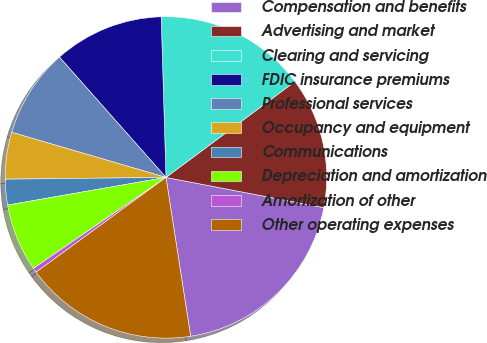<chart> <loc_0><loc_0><loc_500><loc_500><pie_chart><fcel>Compensation and benefits<fcel>Advertising and market<fcel>Clearing and servicing<fcel>FDIC insurance premiums<fcel>Professional services<fcel>Occupancy and equipment<fcel>Communications<fcel>Depreciation and amortization<fcel>Amortization of other<fcel>Other operating expenses<nl><fcel>19.54%<fcel>13.18%<fcel>15.3%<fcel>11.06%<fcel>8.94%<fcel>4.7%<fcel>2.58%<fcel>6.82%<fcel>0.46%<fcel>17.42%<nl></chart> 